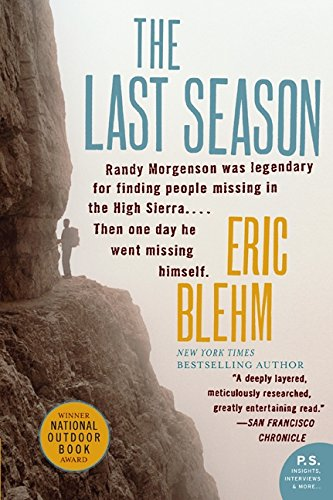Is this a comedy book? No, the book is not in the comedy genre; it thoroughly chronicles the dramatic and real-life events surrounding a wilderness ranger. 